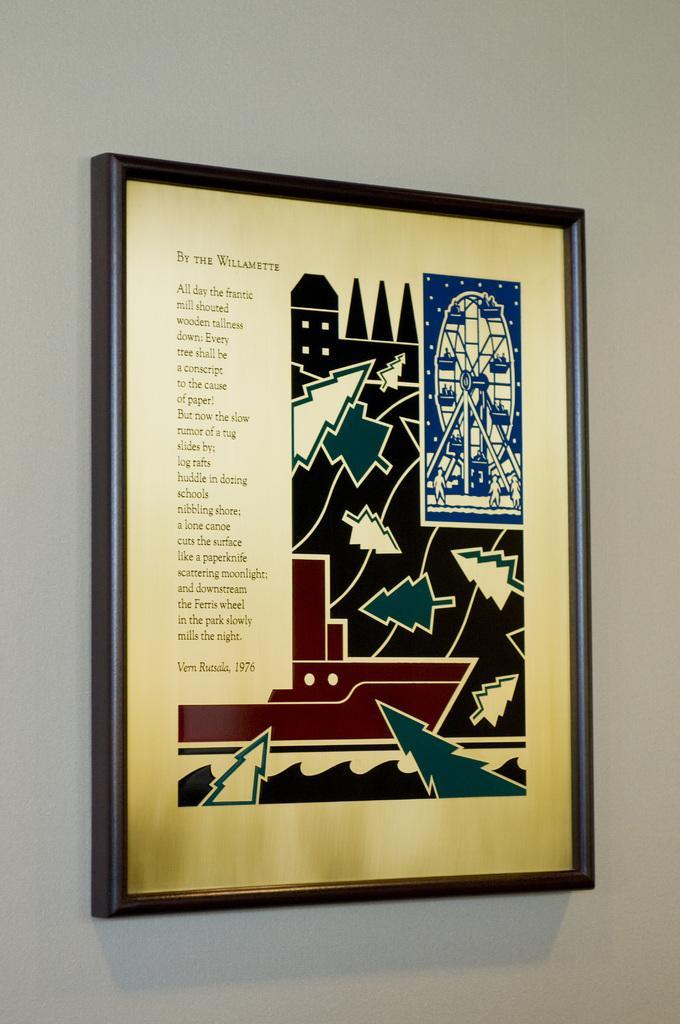How would you summarize this image in a sentence or two? In the picture I can see a photo attached to a white color wall. On this photo frame I can see designs of trees, some other things and something written on it. 